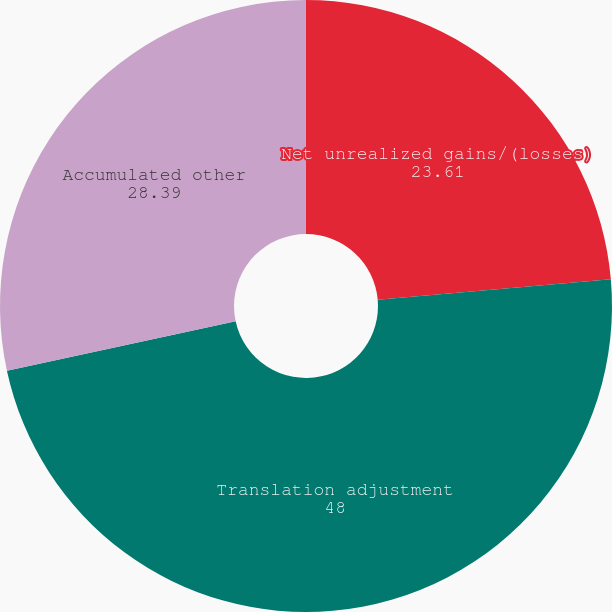<chart> <loc_0><loc_0><loc_500><loc_500><pie_chart><fcel>Net unrealized gains/(losses)<fcel>Translation adjustment<fcel>Accumulated other<nl><fcel>23.61%<fcel>48.0%<fcel>28.39%<nl></chart> 